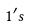Convert formula to latex. <formula><loc_0><loc_0><loc_500><loc_500>1 ^ { \prime } s</formula> 